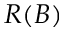<formula> <loc_0><loc_0><loc_500><loc_500>R ( B )</formula> 